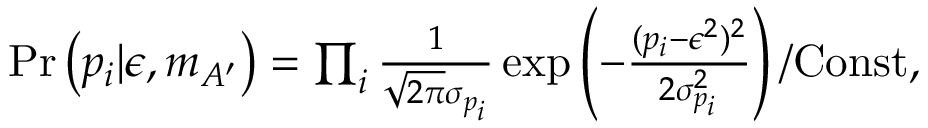<formula> <loc_0><loc_0><loc_500><loc_500>\begin{array} { r } { P r \left ( p _ { i } | \epsilon , m _ { A ^ { \prime } } \right ) = \prod _ { i } \frac { 1 } { \sqrt { 2 \pi } \sigma _ { p _ { i } } } \exp \left ( - \frac { ( p _ { i } - \epsilon ^ { 2 } ) ^ { 2 } } { 2 \sigma _ { p _ { i } } ^ { 2 } } \right ) / C o n s t , } \end{array}</formula> 